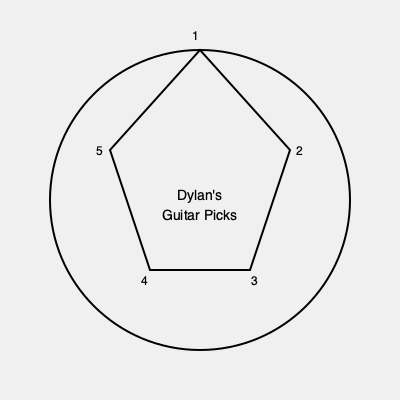Arrange Bob Dylan's guitar picks from his different eras chronologically, starting from the top vertex and moving clockwise. If "1" represents his folk era pick, "2" his electric era pick, "3" his country era pick, "4" his gospel era pick, and "5" his modern era pick, what is the correct arrangement? To solve this puzzle, we need to arrange Dylan's guitar picks chronologically based on his musical eras:

1. Folk era (early 1960s): This was Dylan's earliest prominent era, so it should be placed at the top (position 1).
2. Electric era (mid-1960s): This followed the folk era, so it should be placed next clockwise (position 2).
3. Country era (late 1960s to early 1970s): This came after the electric era, so it goes in position 3.
4. Gospel era (late 1970s to early 1980s): This followed the country era, so it's placed in position 4.
5. Modern era (mid-1980s onwards): This is Dylan's most recent era, so it goes in the last position (5).

Therefore, the correct chronological arrangement, starting from the top and moving clockwise, is: 1, 2, 3, 4, 5.
Answer: 1, 2, 3, 4, 5 